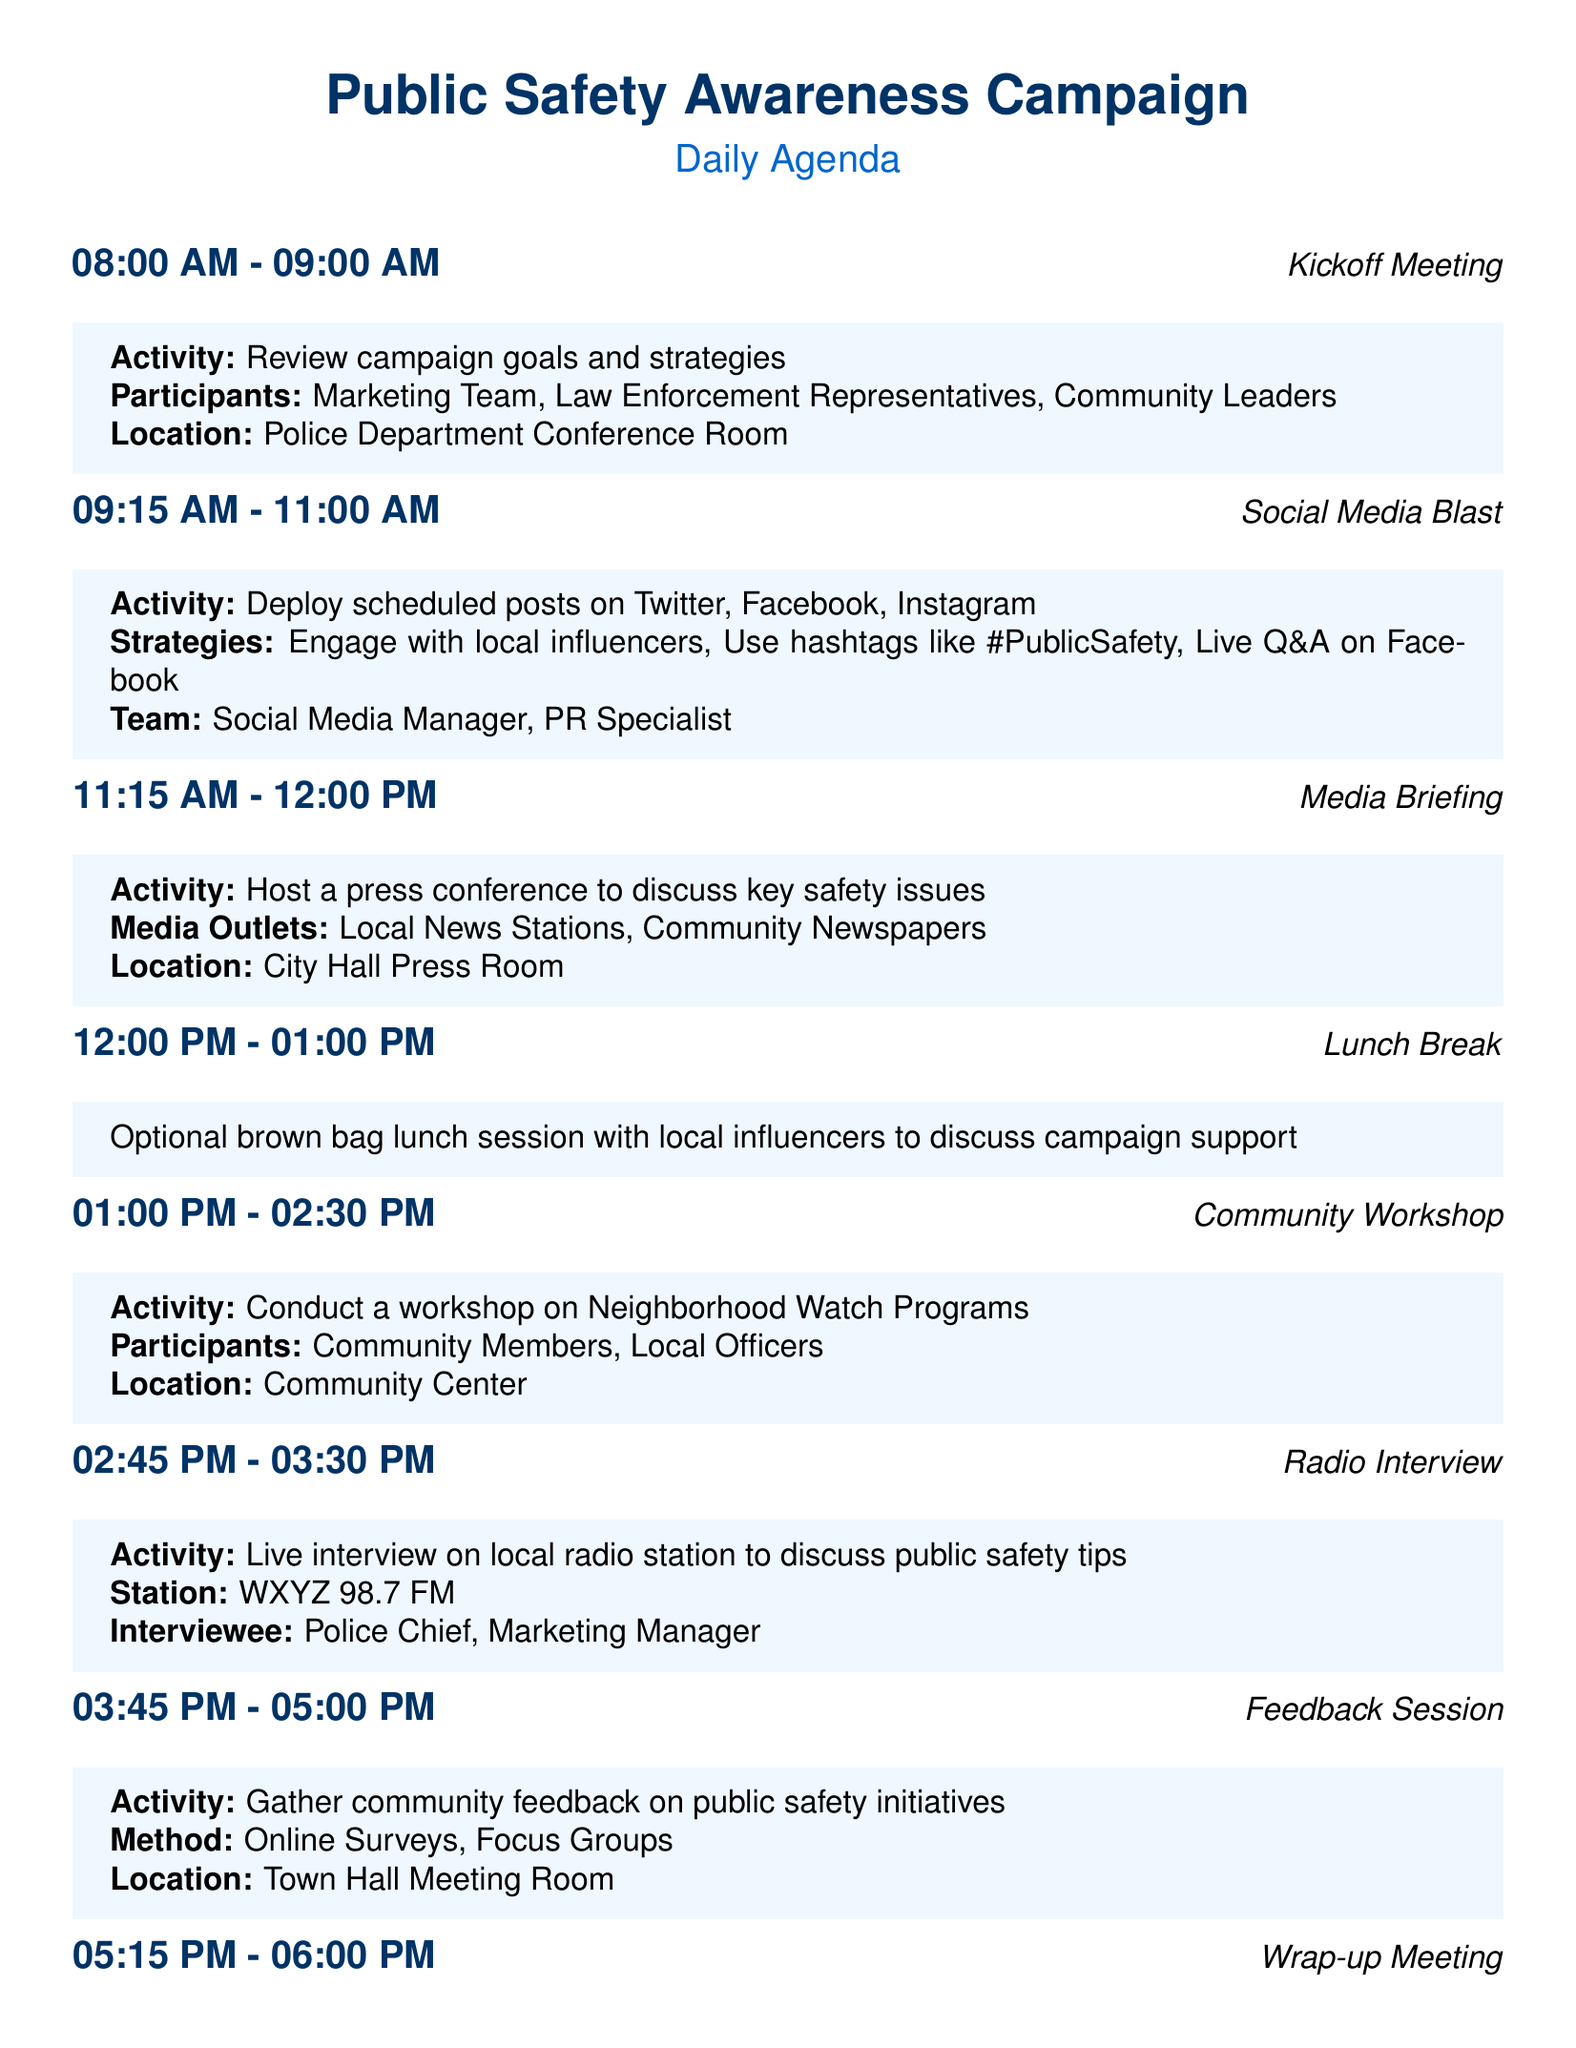What time is the kickoff meeting? The kickoff meeting occurs at the start of the day as indicated in the agenda, which is from 08:00 AM to 09:00 AM.
Answer: 08:00 AM - 09:00 AM Who participates in the kickoff meeting? The document specifies the participants of the kickoff meeting, which includes the Marketing Team, Law Enforcement Representatives, and Community Leaders.
Answer: Marketing Team, Law Enforcement Representatives, Community Leaders What activity takes place during the community workshop? The agenda outlines that the community workshop focuses on conducting a workshop on Neighborhood Watch Programs.
Answer: Conduct a workshop on Neighborhood Watch Programs What media outlet is mentioned for the radio interview? The document refers specifically to the local radio station where the interview is conducted, which is WXYZ 98.7 FM.
Answer: WXYZ 98.7 FM What strategy is included in the social media blast? The strategies for engaging during the social media blast include engaging with local influencers and using specific hashtags.
Answer: Engage with local influencers What is the location of the feedback session? The document clearly identifies the location set for gathering community feedback, which is the Town Hall Meeting Room.
Answer: Town Hall Meeting Room How long is the lunch break scheduled for? The lunch break is mentioned in the agenda with no specific duration stated, but it usually follows a consistent format of one hour based on typical scheduling.
Answer: 01:00 PM - 02:00 PM How many sessions are included in the daily agenda? The document lists a total of seven sessions, counting the kickoff and wrap-up meetings included in the agenda.
Answer: Seven sessions What is a key outcome expected from the wrap-up meeting? The agenda indicates that the wrap-up meeting's activity involves reviewing the day's activities and planning for next steps.
Answer: Review the day's activities and plan next steps 